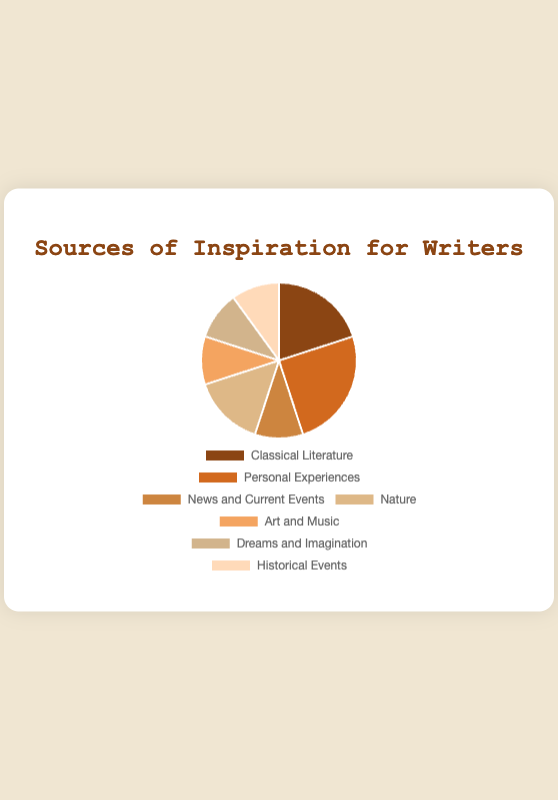Which source of inspiration has the highest percentage? By inspecting the pie chart, "Personal Experiences" has the highest percentage of 25%
Answer: Personal Experiences Which sources of inspiration share the same percentage? The pie chart shows that "News and Current Events", "Art and Music", "Dreams and Imagination", and "Historical Events" each have 10%
Answer: News and Current Events, Art and Music, Dreams and Imagination, Historical Events How much more percentage does "Classical Literature" have compared to "Nature"? "Classical Literature" has 20% and "Nature" has 15%, the difference is 20% - 15% = 5%
Answer: 5% What's the combined percentage of "News and Current Events" and "Art and Music"? Each source has 10%, so the combined percentage is 10% + 10% = 20%
Answer: 20% If you sum up the percentages of "Classical Literature", "Personal Experiences", and "Nature", what do you get? Adding these together: 20% (Classical Literature) + 25% (Personal Experiences) + 15% (Nature) = 60%
Answer: 60% Which source of inspiration has the second highest percentage? The second highest percentage shown in the pie chart, after "Personal Experiences" (25%), is "Classical Literature" (20%)
Answer: Classical Literature How does the percentage of "Dreams and Imagination" compare to "Historical Events"? Both "Dreams and Imagination" and "Historical Events" have the same percentage of 10%
Answer: They are the same What is the average percentage of all the listed inspiration sources? Sum all the percentages: 20% + 25% + 10% + 15% + 10% + 10% + 10% = 100%. There are 7 sources, so the average percentage is 100% / 7 ≈ 14.29%
Answer: 14.29% What percentage is represented by sources that have less than 15% each? "News and Current Events" (10%), "Art and Music" (10%), "Dreams and Imagination" (10%), and "Historical Events" (10%) each have less than 15%. Their sum is 10% + 10% + 10% + 10% = 40%
Answer: 40% Which source(s) are depicted in brown shades? Based on the visual attribute description, the brown shades are used for "Classical Literature", "Personal Experiences", "News and Current Events", "Nature", "Art and Music", and "Dreams and Imagination" as these colors fall within the brown family range mentioned
Answer: Classical Literature, Personal Experiences, News and Current Events, Nature, Art and Music, Dreams and Imagination 